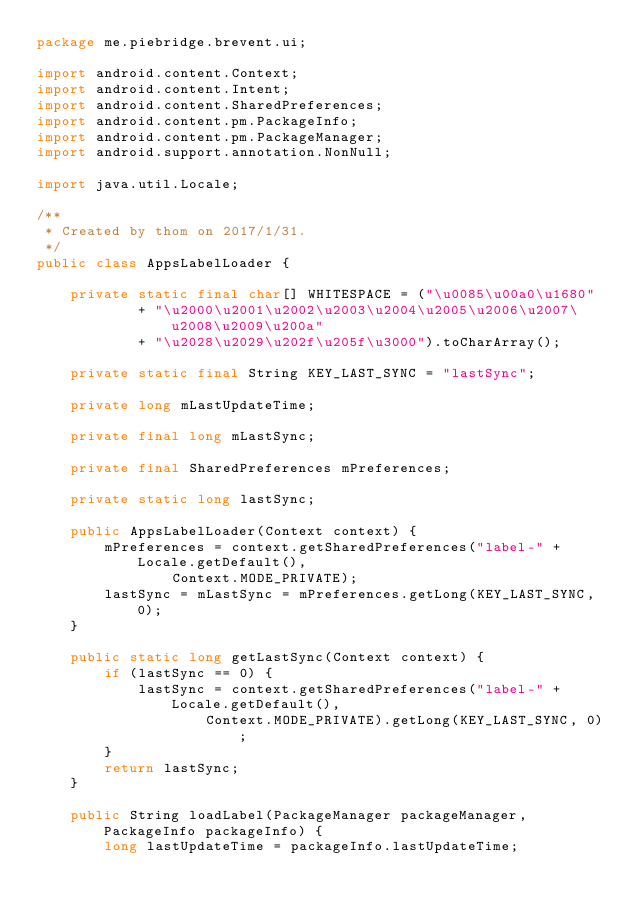<code> <loc_0><loc_0><loc_500><loc_500><_Java_>package me.piebridge.brevent.ui;

import android.content.Context;
import android.content.Intent;
import android.content.SharedPreferences;
import android.content.pm.PackageInfo;
import android.content.pm.PackageManager;
import android.support.annotation.NonNull;

import java.util.Locale;

/**
 * Created by thom on 2017/1/31.
 */
public class AppsLabelLoader {

    private static final char[] WHITESPACE = ("\u0085\u00a0\u1680"
            + "\u2000\u2001\u2002\u2003\u2004\u2005\u2006\u2007\u2008\u2009\u200a"
            + "\u2028\u2029\u202f\u205f\u3000").toCharArray();

    private static final String KEY_LAST_SYNC = "lastSync";

    private long mLastUpdateTime;

    private final long mLastSync;

    private final SharedPreferences mPreferences;

    private static long lastSync;

    public AppsLabelLoader(Context context) {
        mPreferences = context.getSharedPreferences("label-" + Locale.getDefault(),
                Context.MODE_PRIVATE);
        lastSync = mLastSync = mPreferences.getLong(KEY_LAST_SYNC, 0);
    }

    public static long getLastSync(Context context) {
        if (lastSync == 0) {
            lastSync = context.getSharedPreferences("label-" + Locale.getDefault(),
                    Context.MODE_PRIVATE).getLong(KEY_LAST_SYNC, 0);
        }
        return lastSync;
    }

    public String loadLabel(PackageManager packageManager, PackageInfo packageInfo) {
        long lastUpdateTime = packageInfo.lastUpdateTime;</code> 